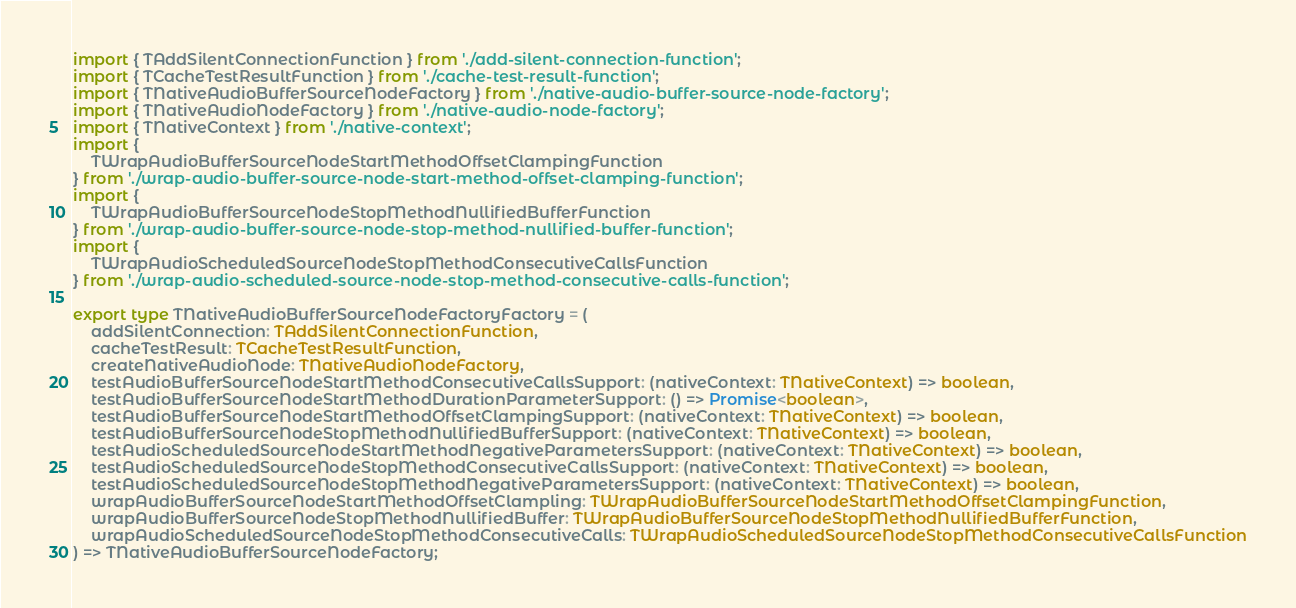Convert code to text. <code><loc_0><loc_0><loc_500><loc_500><_TypeScript_>import { TAddSilentConnectionFunction } from './add-silent-connection-function';
import { TCacheTestResultFunction } from './cache-test-result-function';
import { TNativeAudioBufferSourceNodeFactory } from './native-audio-buffer-source-node-factory';
import { TNativeAudioNodeFactory } from './native-audio-node-factory';
import { TNativeContext } from './native-context';
import {
    TWrapAudioBufferSourceNodeStartMethodOffsetClampingFunction
} from './wrap-audio-buffer-source-node-start-method-offset-clamping-function';
import {
    TWrapAudioBufferSourceNodeStopMethodNullifiedBufferFunction
} from './wrap-audio-buffer-source-node-stop-method-nullified-buffer-function';
import {
    TWrapAudioScheduledSourceNodeStopMethodConsecutiveCallsFunction
} from './wrap-audio-scheduled-source-node-stop-method-consecutive-calls-function';

export type TNativeAudioBufferSourceNodeFactoryFactory = (
    addSilentConnection: TAddSilentConnectionFunction,
    cacheTestResult: TCacheTestResultFunction,
    createNativeAudioNode: TNativeAudioNodeFactory,
    testAudioBufferSourceNodeStartMethodConsecutiveCallsSupport: (nativeContext: TNativeContext) => boolean,
    testAudioBufferSourceNodeStartMethodDurationParameterSupport: () => Promise<boolean>,
    testAudioBufferSourceNodeStartMethodOffsetClampingSupport: (nativeContext: TNativeContext) => boolean,
    testAudioBufferSourceNodeStopMethodNullifiedBufferSupport: (nativeContext: TNativeContext) => boolean,
    testAudioScheduledSourceNodeStartMethodNegativeParametersSupport: (nativeContext: TNativeContext) => boolean,
    testAudioScheduledSourceNodeStopMethodConsecutiveCallsSupport: (nativeContext: TNativeContext) => boolean,
    testAudioScheduledSourceNodeStopMethodNegativeParametersSupport: (nativeContext: TNativeContext) => boolean,
    wrapAudioBufferSourceNodeStartMethodOffsetClampling: TWrapAudioBufferSourceNodeStartMethodOffsetClampingFunction,
    wrapAudioBufferSourceNodeStopMethodNullifiedBuffer: TWrapAudioBufferSourceNodeStopMethodNullifiedBufferFunction,
    wrapAudioScheduledSourceNodeStopMethodConsecutiveCalls: TWrapAudioScheduledSourceNodeStopMethodConsecutiveCallsFunction
) => TNativeAudioBufferSourceNodeFactory;
</code> 